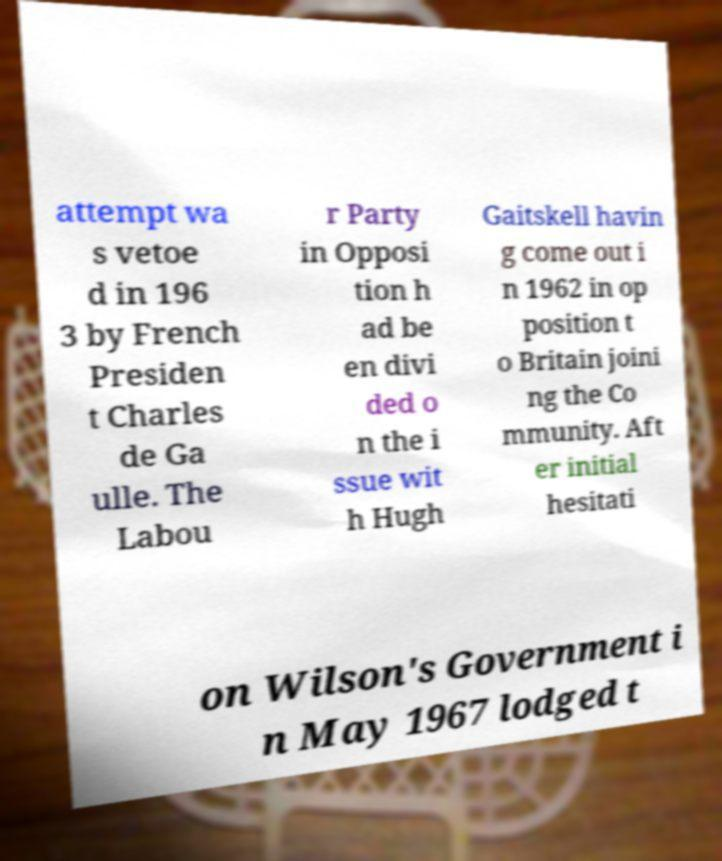There's text embedded in this image that I need extracted. Can you transcribe it verbatim? attempt wa s vetoe d in 196 3 by French Presiden t Charles de Ga ulle. The Labou r Party in Opposi tion h ad be en divi ded o n the i ssue wit h Hugh Gaitskell havin g come out i n 1962 in op position t o Britain joini ng the Co mmunity. Aft er initial hesitati on Wilson's Government i n May 1967 lodged t 